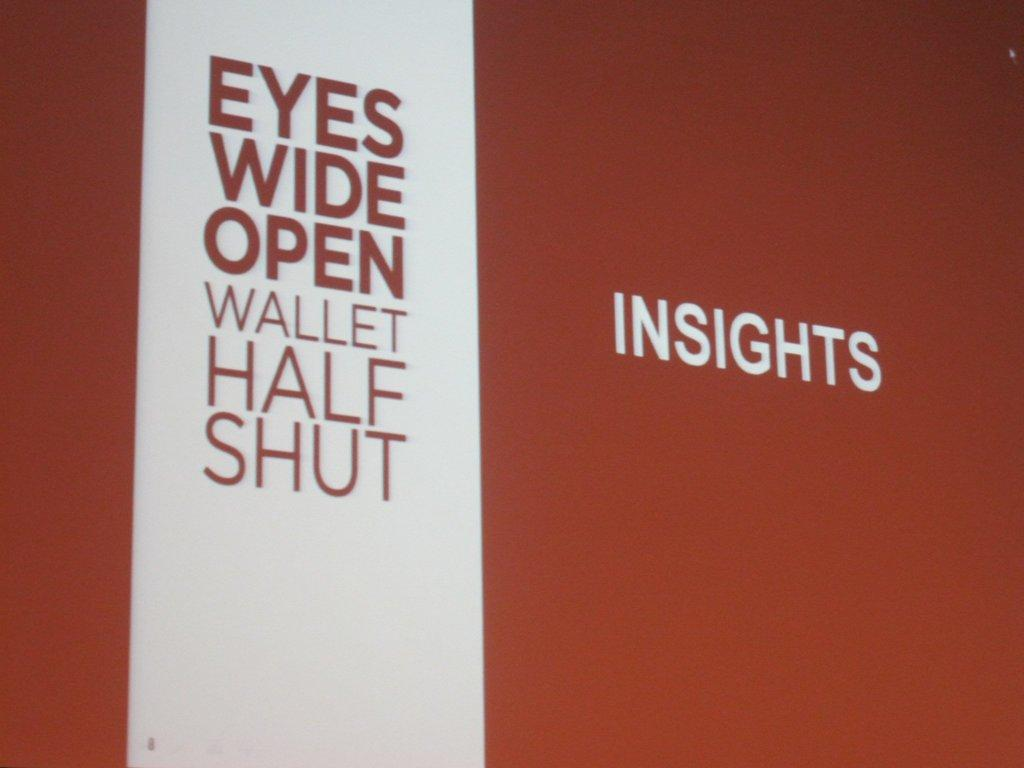<image>
Relay a brief, clear account of the picture shown. Sign on a wall that says Insights and "Eyes Wide Open". 